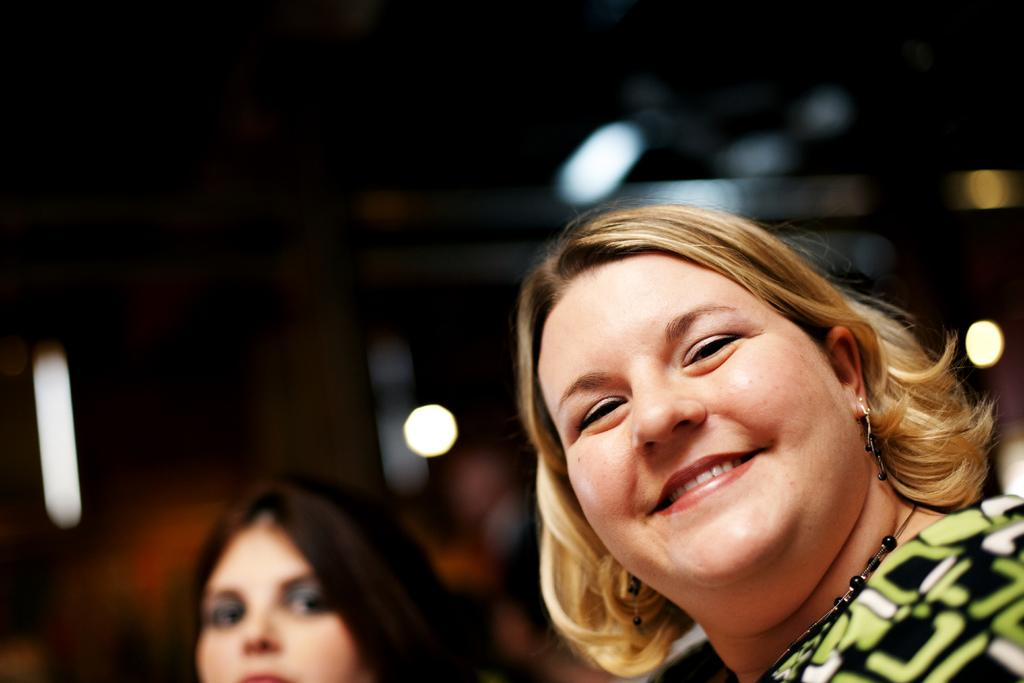What is the primary subject of the image? There is a person in the image. What is the facial expression of the person? The person is smiling. Can you describe the person's surroundings? There is another person beside the smiling person. What can be seen in the background of the image? There are lights visible in the background of the image. What type of comfort can be seen being provided by the truck in the image? There is no truck present in the image, so comfort cannot be provided by a truck. 